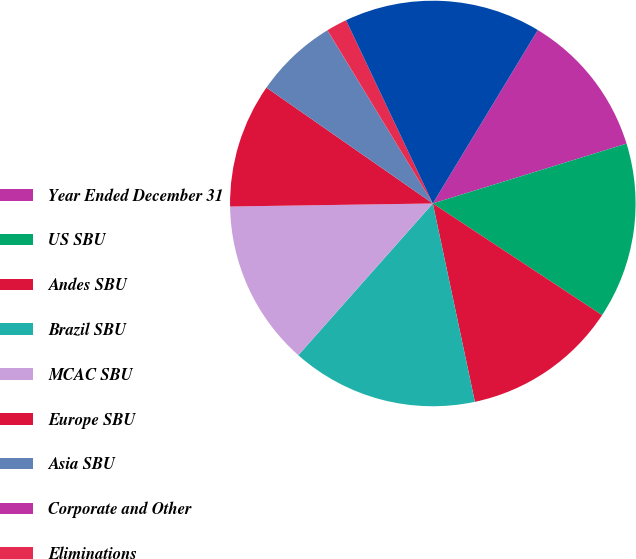Convert chart. <chart><loc_0><loc_0><loc_500><loc_500><pie_chart><fcel>Year Ended December 31<fcel>US SBU<fcel>Andes SBU<fcel>Brazil SBU<fcel>MCAC SBU<fcel>Europe SBU<fcel>Asia SBU<fcel>Corporate and Other<fcel>Eliminations<fcel>Total Revenue<nl><fcel>11.57%<fcel>14.05%<fcel>12.39%<fcel>14.87%<fcel>13.22%<fcel>9.92%<fcel>6.61%<fcel>0.01%<fcel>1.66%<fcel>15.7%<nl></chart> 